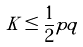<formula> <loc_0><loc_0><loc_500><loc_500>K \leq \frac { 1 } { 2 } p q</formula> 